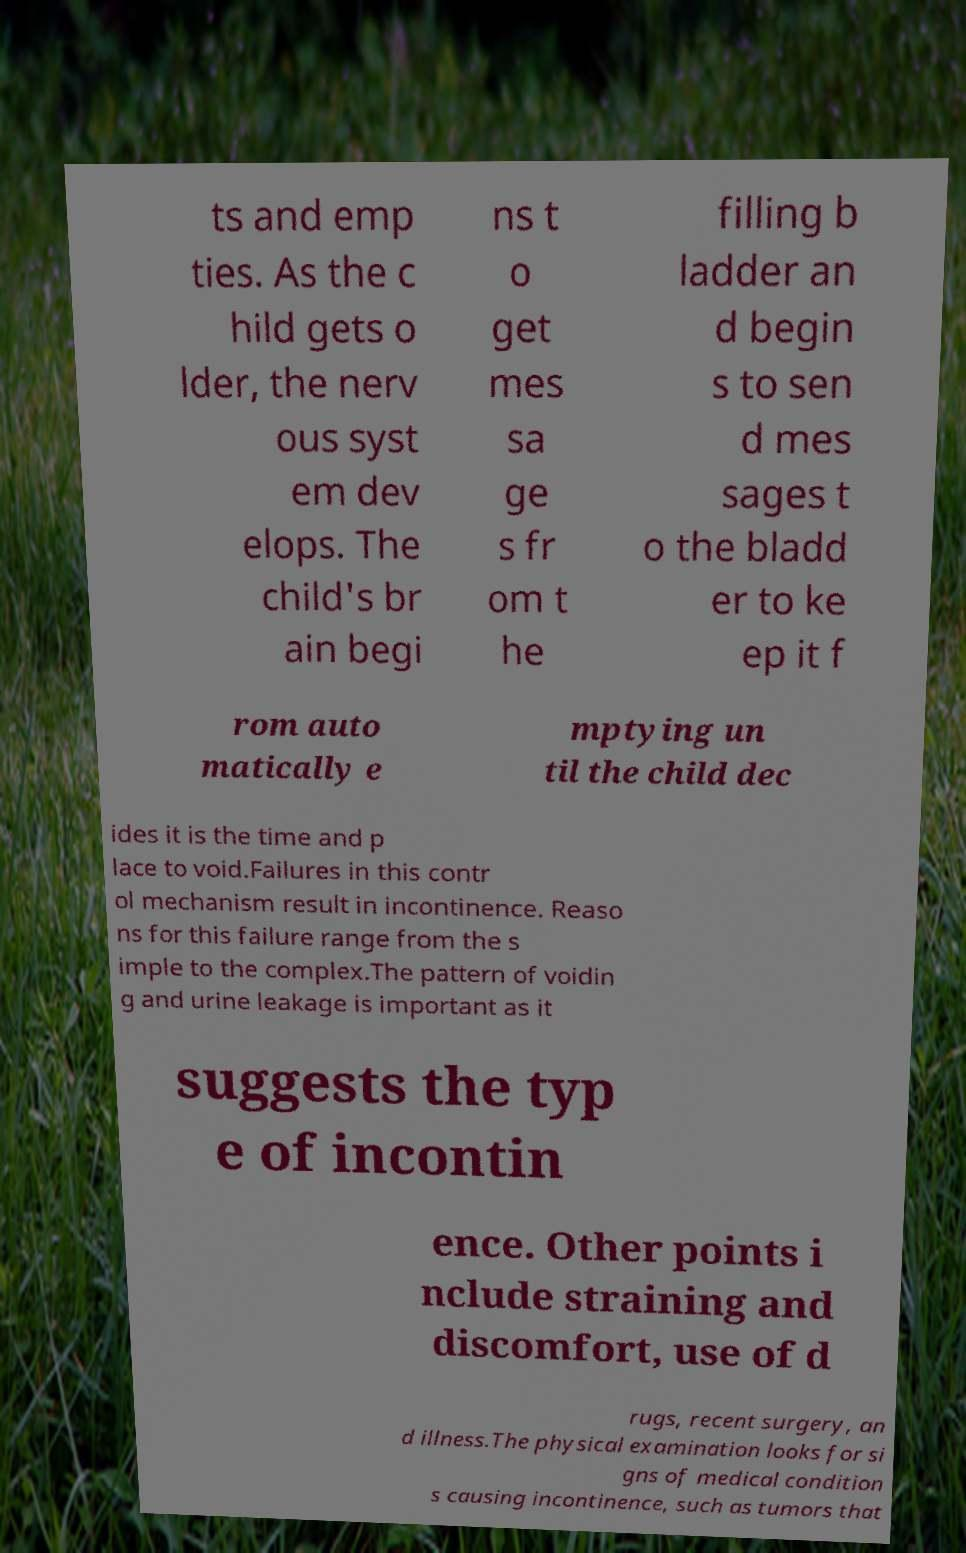Could you assist in decoding the text presented in this image and type it out clearly? ts and emp ties. As the c hild gets o lder, the nerv ous syst em dev elops. The child's br ain begi ns t o get mes sa ge s fr om t he filling b ladder an d begin s to sen d mes sages t o the bladd er to ke ep it f rom auto matically e mptying un til the child dec ides it is the time and p lace to void.Failures in this contr ol mechanism result in incontinence. Reaso ns for this failure range from the s imple to the complex.The pattern of voidin g and urine leakage is important as it suggests the typ e of incontin ence. Other points i nclude straining and discomfort, use of d rugs, recent surgery, an d illness.The physical examination looks for si gns of medical condition s causing incontinence, such as tumors that 